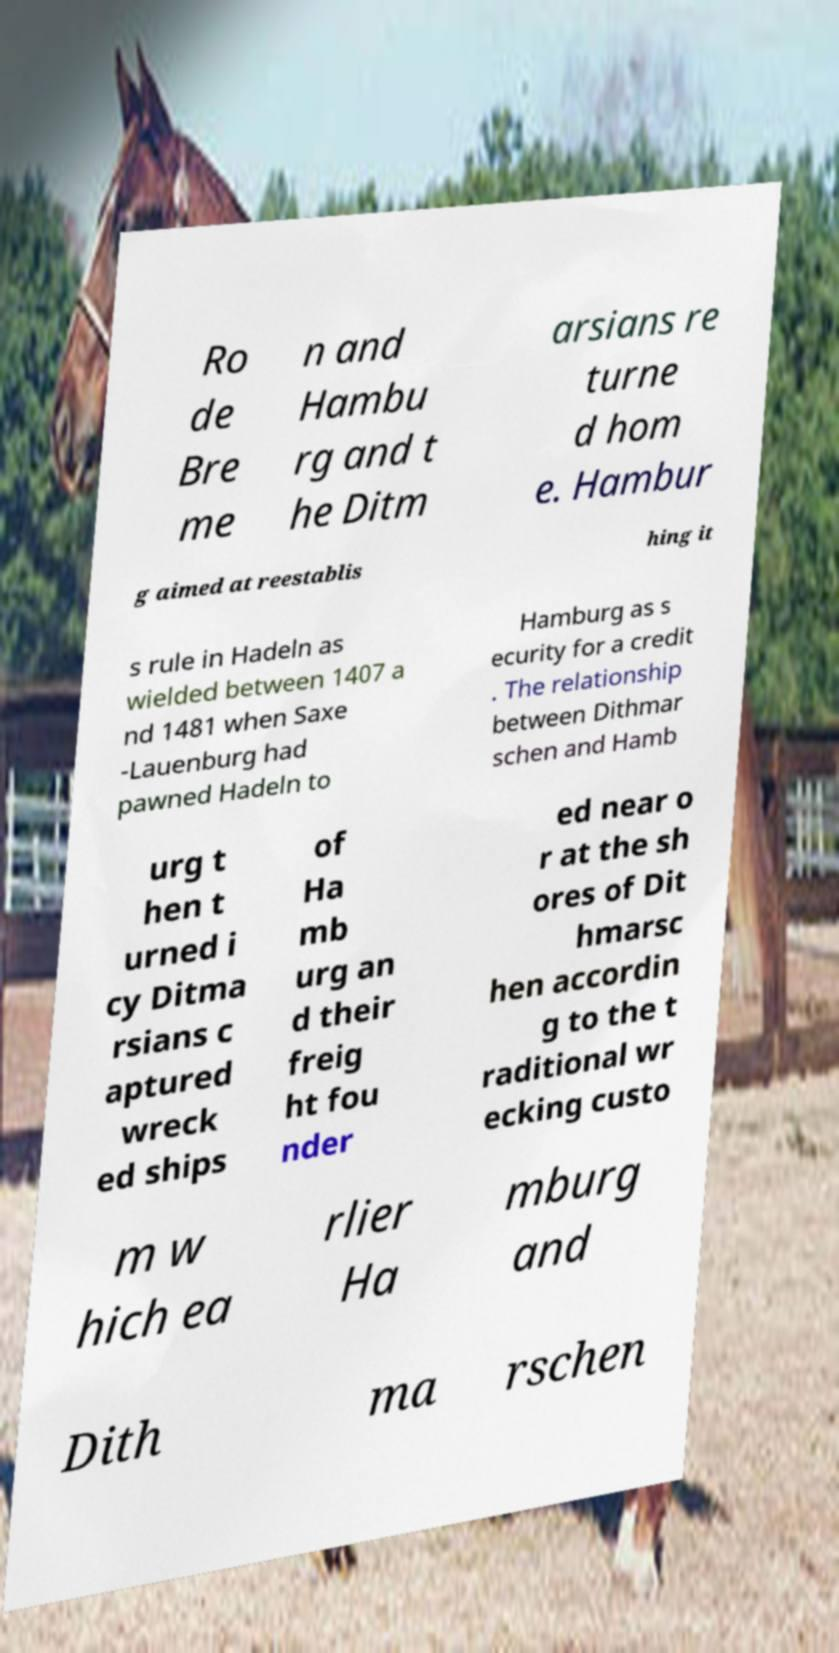There's text embedded in this image that I need extracted. Can you transcribe it verbatim? Ro de Bre me n and Hambu rg and t he Ditm arsians re turne d hom e. Hambur g aimed at reestablis hing it s rule in Hadeln as wielded between 1407 a nd 1481 when Saxe -Lauenburg had pawned Hadeln to Hamburg as s ecurity for a credit . The relationship between Dithmar schen and Hamb urg t hen t urned i cy Ditma rsians c aptured wreck ed ships of Ha mb urg an d their freig ht fou nder ed near o r at the sh ores of Dit hmarsc hen accordin g to the t raditional wr ecking custo m w hich ea rlier Ha mburg and Dith ma rschen 